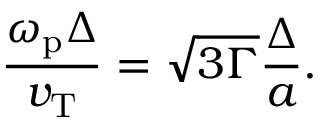<formula> <loc_0><loc_0><loc_500><loc_500>\frac { \omega _ { p } \Delta } { v _ { T } } = \sqrt { 3 \Gamma } \frac { \Delta } { a } .</formula> 